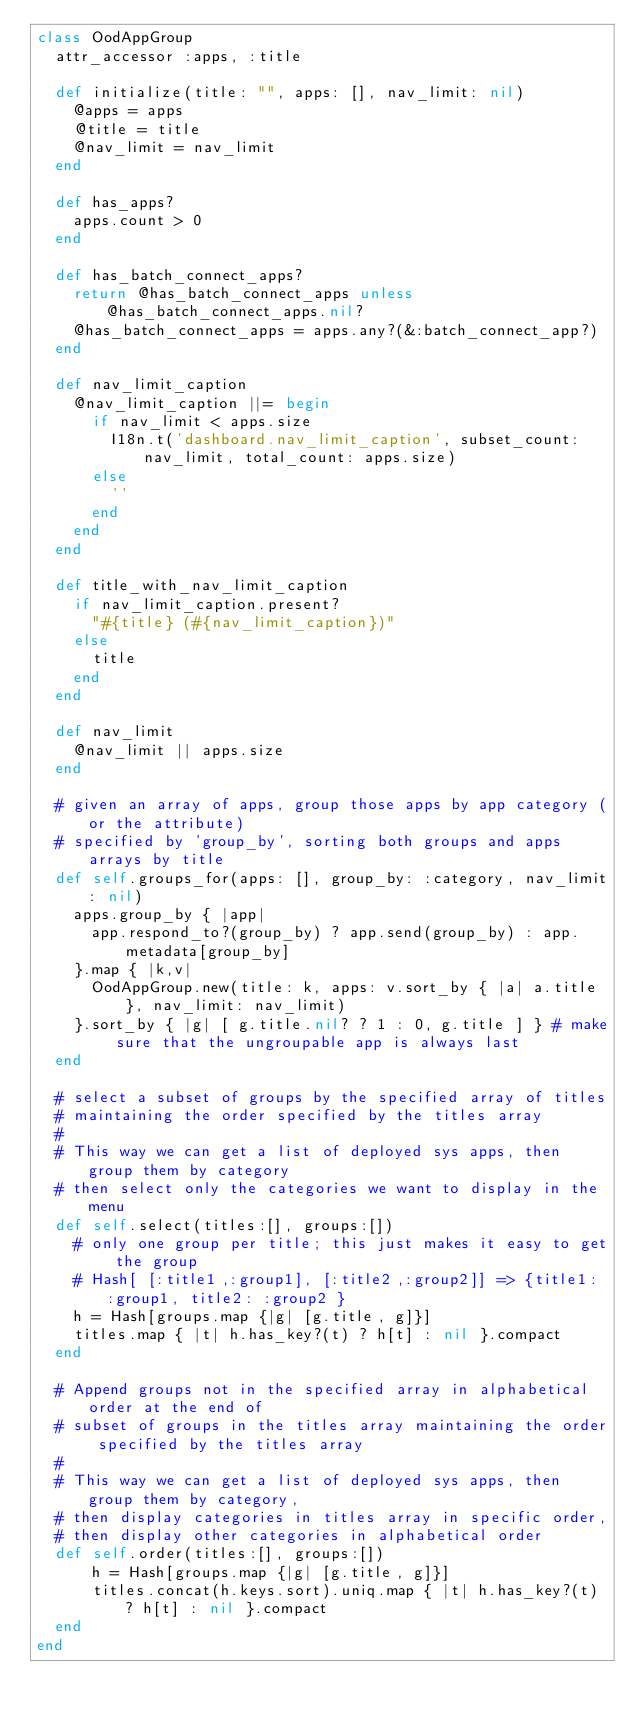<code> <loc_0><loc_0><loc_500><loc_500><_Ruby_>class OodAppGroup
  attr_accessor :apps, :title

  def initialize(title: "", apps: [], nav_limit: nil)
    @apps = apps
    @title = title
    @nav_limit = nav_limit
  end

  def has_apps?
    apps.count > 0
  end

  def has_batch_connect_apps?
    return @has_batch_connect_apps unless @has_batch_connect_apps.nil?
    @has_batch_connect_apps = apps.any?(&:batch_connect_app?)
  end

  def nav_limit_caption
    @nav_limit_caption ||= begin
      if nav_limit < apps.size
        I18n.t('dashboard.nav_limit_caption', subset_count: nav_limit, total_count: apps.size)
      else
        ''
      end
    end
  end

  def title_with_nav_limit_caption
    if nav_limit_caption.present?
      "#{title} (#{nav_limit_caption})"
    else
      title
    end
  end

  def nav_limit
    @nav_limit || apps.size
  end

  # given an array of apps, group those apps by app category (or the attribute)
  # specified by 'group_by', sorting both groups and apps arrays by title
  def self.groups_for(apps: [], group_by: :category, nav_limit: nil)
    apps.group_by { |app|
      app.respond_to?(group_by) ? app.send(group_by) : app.metadata[group_by]
    }.map { |k,v|
      OodAppGroup.new(title: k, apps: v.sort_by { |a| a.title }, nav_limit: nav_limit)
    }.sort_by { |g| [ g.title.nil? ? 1 : 0, g.title ] } # make sure that the ungroupable app is always last
  end

  # select a subset of groups by the specified array of titles
  # maintaining the order specified by the titles array
  #
  # This way we can get a list of deployed sys apps, then group them by category
  # then select only the categories we want to display in the menu
  def self.select(titles:[], groups:[])
    # only one group per title; this just makes it easy to get the group
    # Hash[ [:title1,:group1], [:title2,:group2]] => {title1: :group1, title2: :group2 }
    h = Hash[groups.map {|g| [g.title, g]}]
    titles.map { |t| h.has_key?(t) ? h[t] : nil }.compact
  end
  
  # Append groups not in the specified array in alphabetical order at the end of
  # subset of groups in the titles array maintaining the order specified by the titles array
  #
  # This way we can get a list of deployed sys apps, then group them by category,
  # then display categories in titles array in specific order,
  # then display other categories in alphabetical order
  def self.order(titles:[], groups:[])
      h = Hash[groups.map {|g| [g.title, g]}]
      titles.concat(h.keys.sort).uniq.map { |t| h.has_key?(t) ? h[t] : nil }.compact 
  end
end
</code> 